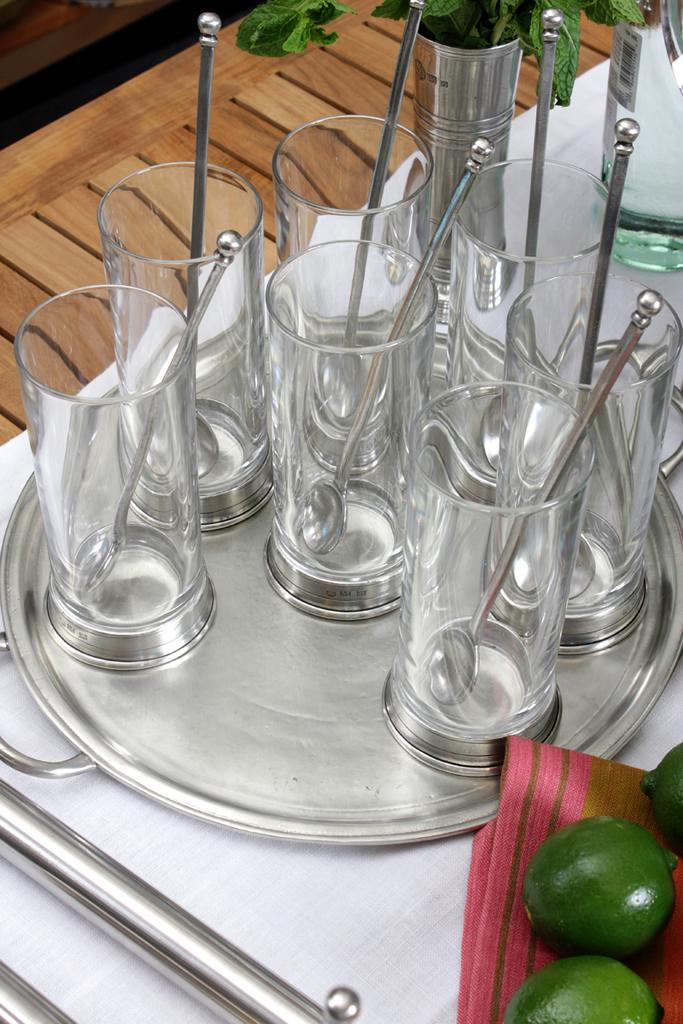What objects can be seen in the foreground of the image? There are glasses, spoons, a platter, a white cloth, a wooden surface, and a bottle in the foreground of the image. What is placed on the white cloth? There are fruits on the white cloth. What type of surface is visible in the foreground of the image? There is a wooden surface in the foreground of the image. What is the color of the cloth in the foreground of the image? The cloth in the foreground of the image is white. Can you tell me how many cameras are visible in the image? There are no cameras visible in the image. What type of footwear is being worn by the person in the image? There is no person present in the image, so it is not possible to determine what type of footwear they might be wearing. 